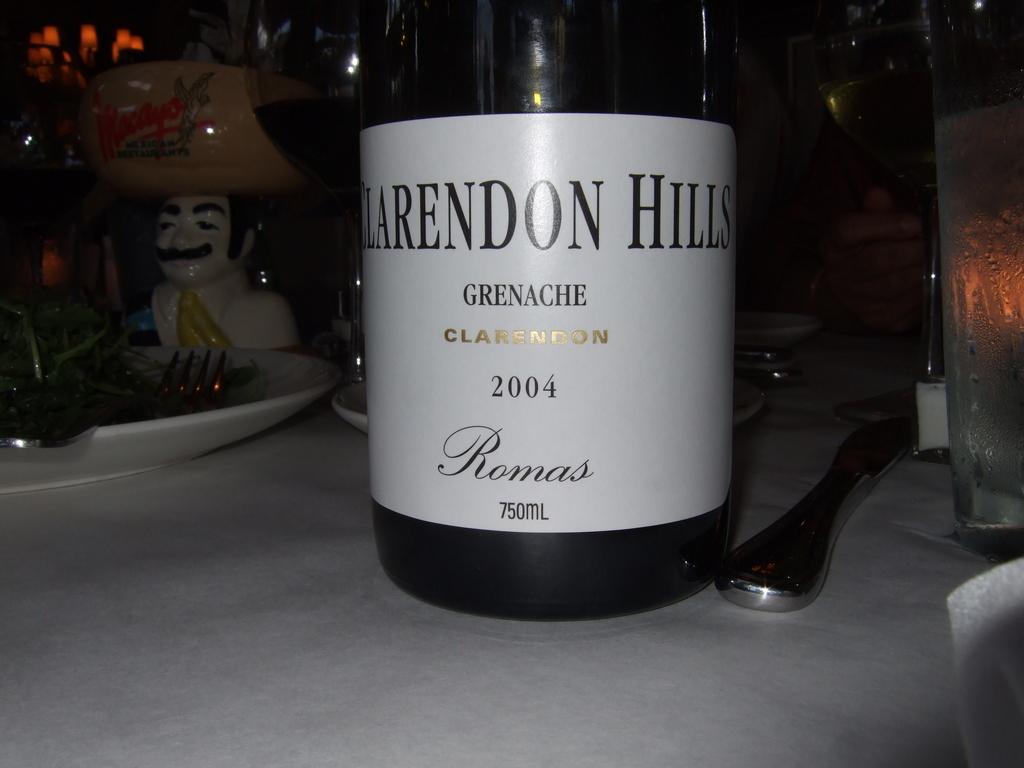What year is the wine?
Keep it short and to the point. 2004. 